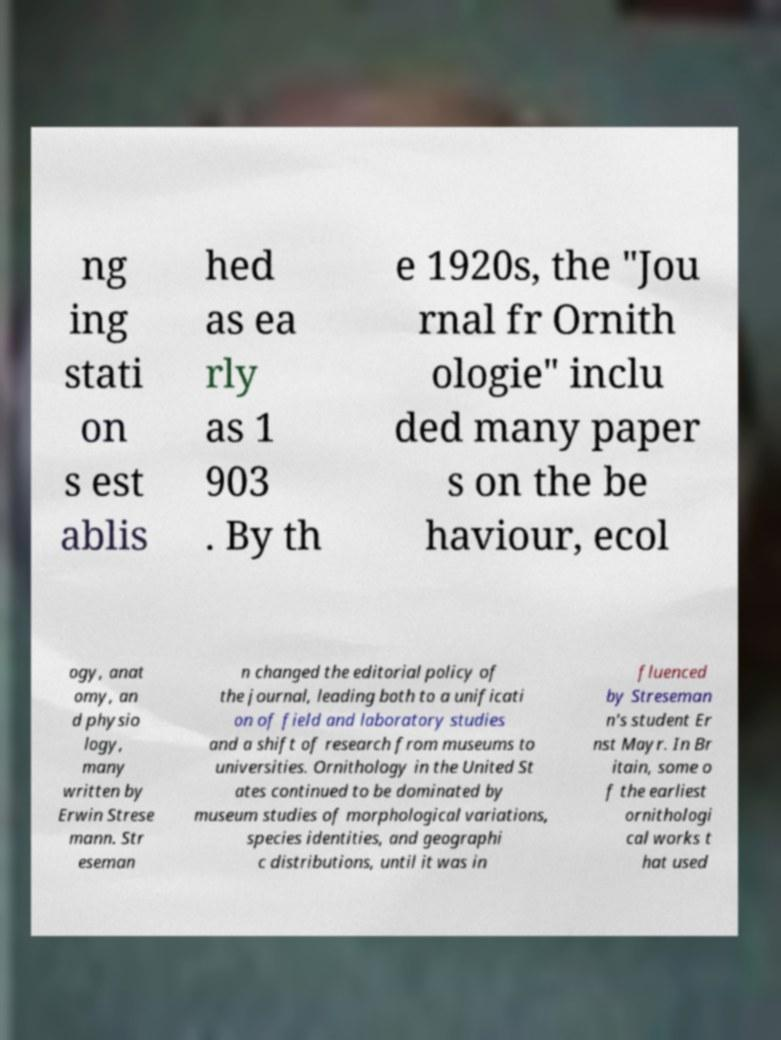For documentation purposes, I need the text within this image transcribed. Could you provide that? ng ing stati on s est ablis hed as ea rly as 1 903 . By th e 1920s, the "Jou rnal fr Ornith ologie" inclu ded many paper s on the be haviour, ecol ogy, anat omy, an d physio logy, many written by Erwin Strese mann. Str eseman n changed the editorial policy of the journal, leading both to a unificati on of field and laboratory studies and a shift of research from museums to universities. Ornithology in the United St ates continued to be dominated by museum studies of morphological variations, species identities, and geographi c distributions, until it was in fluenced by Streseman n's student Er nst Mayr. In Br itain, some o f the earliest ornithologi cal works t hat used 